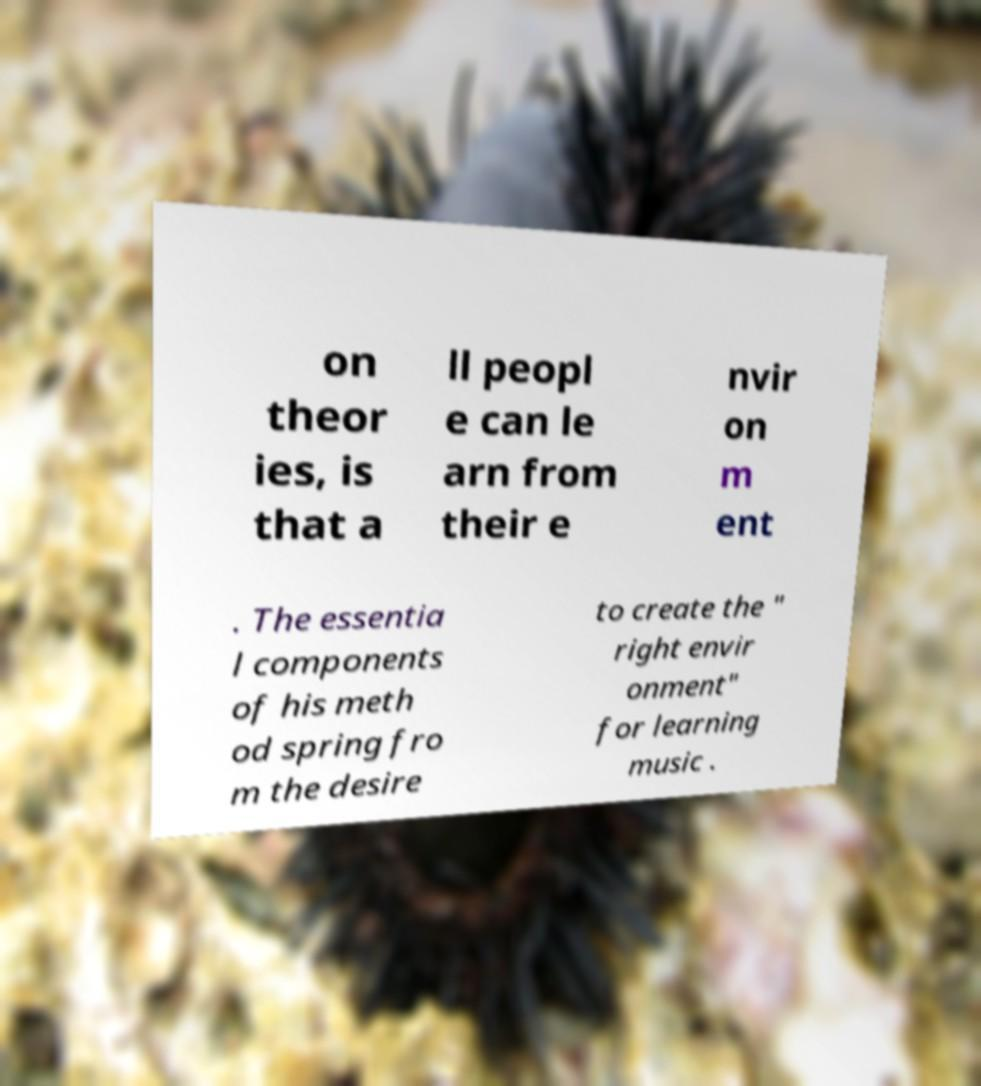What messages or text are displayed in this image? I need them in a readable, typed format. on theor ies, is that a ll peopl e can le arn from their e nvir on m ent . The essentia l components of his meth od spring fro m the desire to create the " right envir onment" for learning music . 